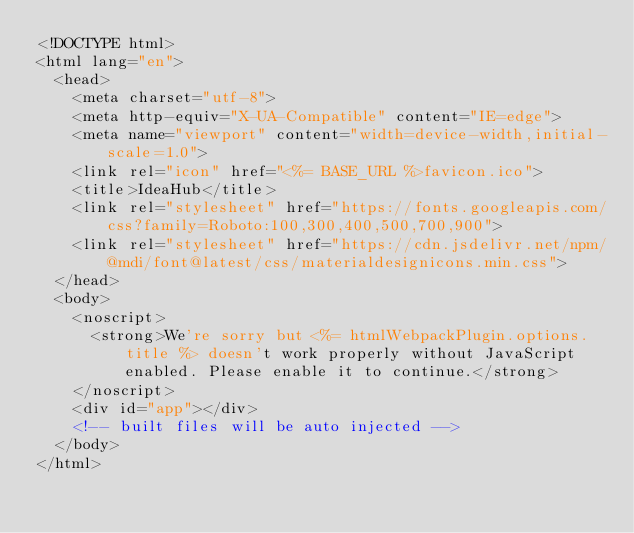<code> <loc_0><loc_0><loc_500><loc_500><_HTML_><!DOCTYPE html>
<html lang="en">
  <head>
    <meta charset="utf-8">
    <meta http-equiv="X-UA-Compatible" content="IE=edge">
    <meta name="viewport" content="width=device-width,initial-scale=1.0">
    <link rel="icon" href="<%= BASE_URL %>favicon.ico">
    <title>IdeaHub</title>
    <link rel="stylesheet" href="https://fonts.googleapis.com/css?family=Roboto:100,300,400,500,700,900">
    <link rel="stylesheet" href="https://cdn.jsdelivr.net/npm/@mdi/font@latest/css/materialdesignicons.min.css">
  </head>
  <body>
    <noscript>
      <strong>We're sorry but <%= htmlWebpackPlugin.options.title %> doesn't work properly without JavaScript enabled. Please enable it to continue.</strong>
    </noscript>
    <div id="app"></div>
    <!-- built files will be auto injected -->
  </body>
</html>
</code> 